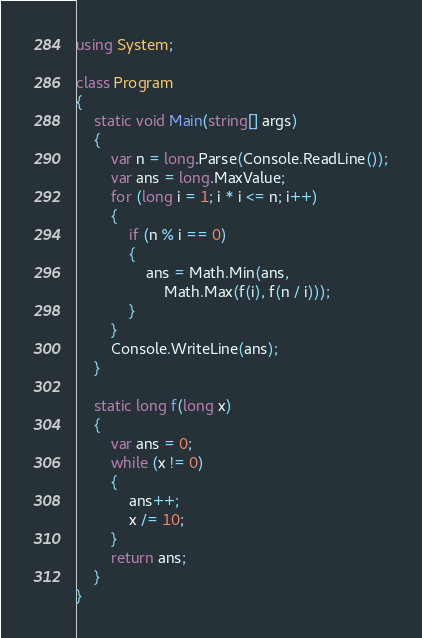<code> <loc_0><loc_0><loc_500><loc_500><_C#_>using System;

class Program
{
    static void Main(string[] args)
    {
        var n = long.Parse(Console.ReadLine());
        var ans = long.MaxValue;
        for (long i = 1; i * i <= n; i++)
        {
            if (n % i == 0)
            {
                ans = Math.Min(ans,
                    Math.Max(f(i), f(n / i)));
            }
        }
        Console.WriteLine(ans);
    }

    static long f(long x)
    {
        var ans = 0;
        while (x != 0)
        {
            ans++;
            x /= 10;
        }
        return ans;
    }
}
</code> 